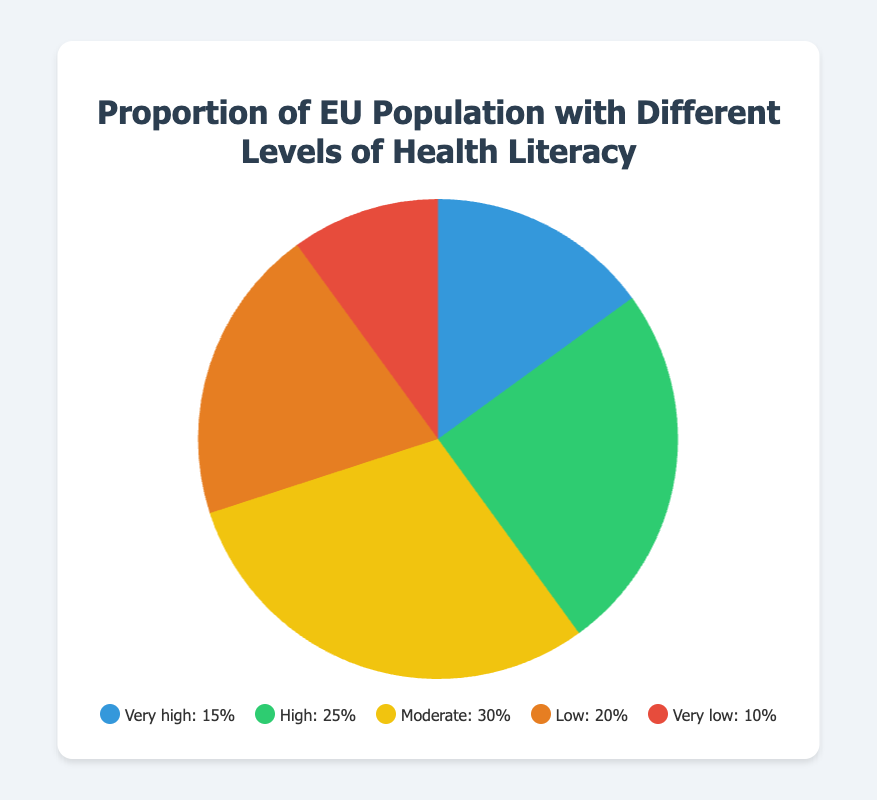What's the proportion of the population with high and very high health literacy combined? Sum the percentages of both 'High' and 'Very high' categories. 'High' is 25% and 'Very high' is 15%. So, 25% + 15% = 40%
Answer: 40% Which health literacy level has the highest proportion of the population? By comparing the percentages of all the health literacy levels, 'Moderate' has the highest proportion, which is 30%.
Answer: Moderate What is the difference in the proportion between the lowest and highest health literacy levels? The highest proportion is 'Moderate' with 30% and the lowest is 'Very low' with 10%. The difference is 30% - 10% = 20%
Answer: 20% How many levels have a proportion of 20% or higher? By evaluating each level: 'Very high' (15%), 'High' (25%), 'Moderate' (30%), 'Low' (20%), 'Very low' (10%). Three levels ('High', 'Moderate', 'Low') have 20% or higher.
Answer: 3 Which two health literacy levels have proportions that add up to the same value as the 'Moderate' level? Find two categories whose sums equal 30%. 'High' is 25% and 'Very low' is 10%. 25% + 10% = 35%, 'Very high' is 15% and 'Low' is 20%. 15% + 20% = 35%. Only 'Very high' and 'Low' add up to 'Moderate' level.
Answer: Very high and Low What color represents the 'Very low' health literacy level? According to the visual attributes, 'Very low' health literacy is represented by the red color.
Answer: Red Which level has a smaller proportion, 'High' or 'Low'? The 'Low' level has a proportion of 20%, and the 'High' level has a proportion of 25%. Thus, 'Low' is smaller than 'High'.
Answer: Low What is the combined proportion of the population with either 'Low' or 'Very low' health literacy? Sum the percentages of 'Low' and 'Very low' categories. 'Low' is 20%, and 'Very low' is 10%. So, 20% + 10% = 30%
Answer: 30% 